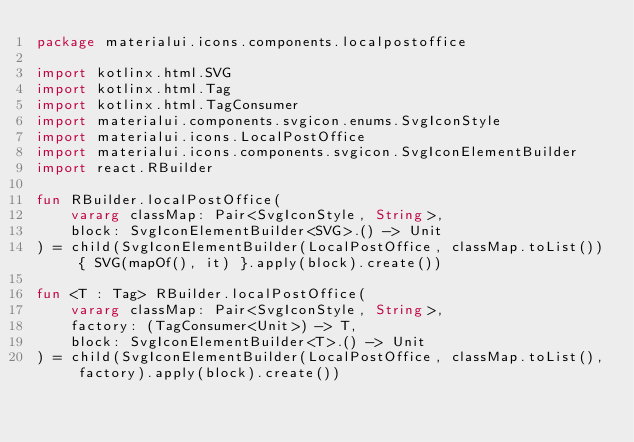<code> <loc_0><loc_0><loc_500><loc_500><_Kotlin_>package materialui.icons.components.localpostoffice

import kotlinx.html.SVG
import kotlinx.html.Tag
import kotlinx.html.TagConsumer
import materialui.components.svgicon.enums.SvgIconStyle
import materialui.icons.LocalPostOffice
import materialui.icons.components.svgicon.SvgIconElementBuilder
import react.RBuilder

fun RBuilder.localPostOffice(
    vararg classMap: Pair<SvgIconStyle, String>,
    block: SvgIconElementBuilder<SVG>.() -> Unit
) = child(SvgIconElementBuilder(LocalPostOffice, classMap.toList()) { SVG(mapOf(), it) }.apply(block).create())

fun <T : Tag> RBuilder.localPostOffice(
    vararg classMap: Pair<SvgIconStyle, String>,
    factory: (TagConsumer<Unit>) -> T,
    block: SvgIconElementBuilder<T>.() -> Unit
) = child(SvgIconElementBuilder(LocalPostOffice, classMap.toList(), factory).apply(block).create())
</code> 